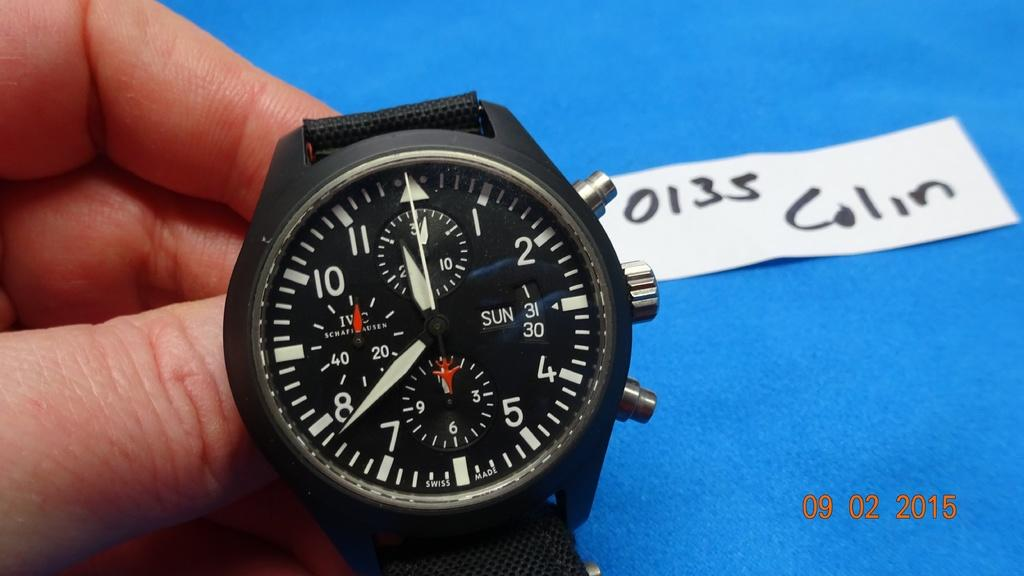Provide a one-sentence caption for the provided image. A watch is presented with a 0135 Colin label. 